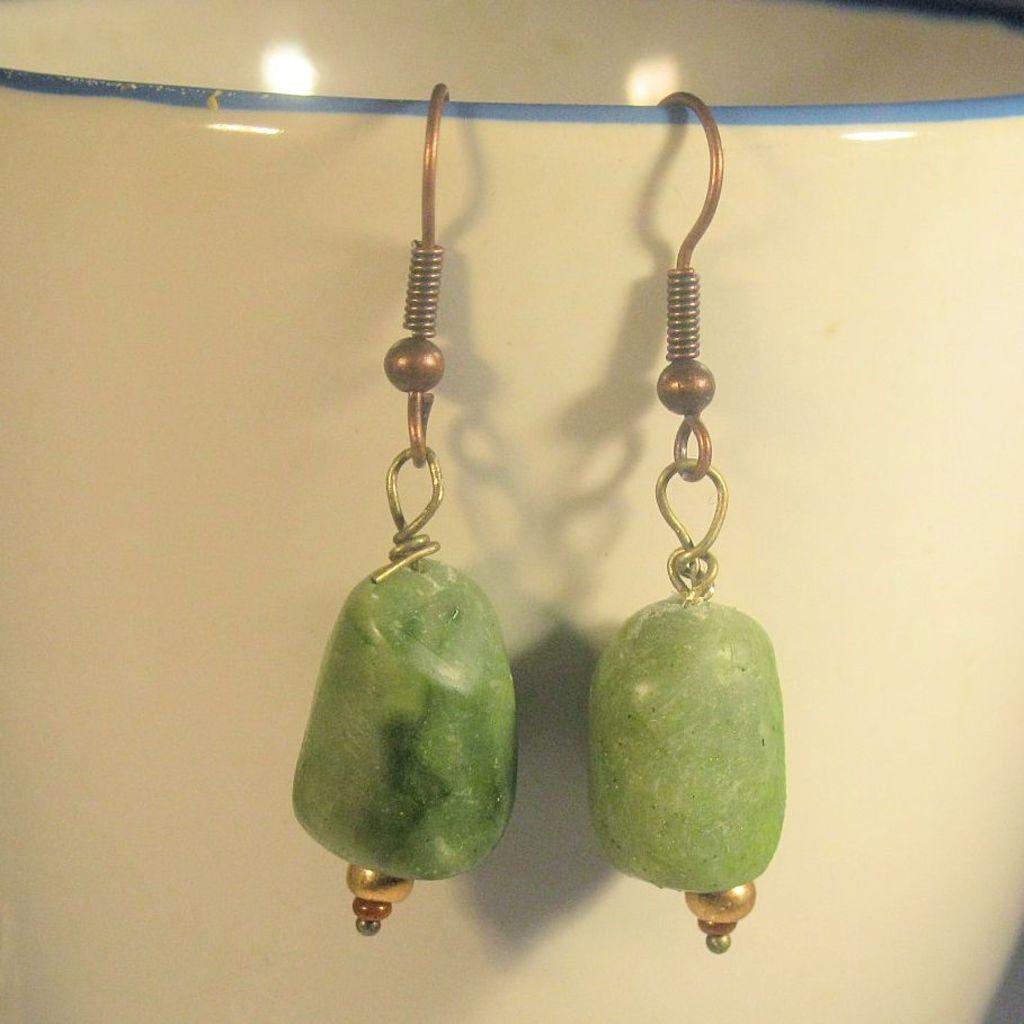Describe this image in one or two sentences. There are earrings hanging to the rope, this is wall. 